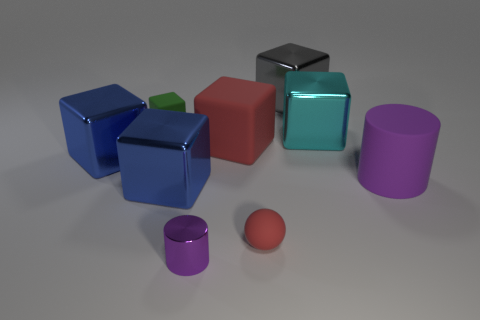Add 1 small blue matte cubes. How many objects exist? 10 Subtract all large red matte blocks. How many blocks are left? 5 Subtract all yellow cylinders. How many blue cubes are left? 2 Subtract all cyan cubes. How many cubes are left? 5 Subtract 1 cylinders. How many cylinders are left? 1 Subtract all cylinders. How many objects are left? 7 Add 6 cyan metal things. How many cyan metal things exist? 7 Subtract 0 green cylinders. How many objects are left? 9 Subtract all cyan balls. Subtract all green blocks. How many balls are left? 1 Subtract all big red rubber blocks. Subtract all big red matte cubes. How many objects are left? 7 